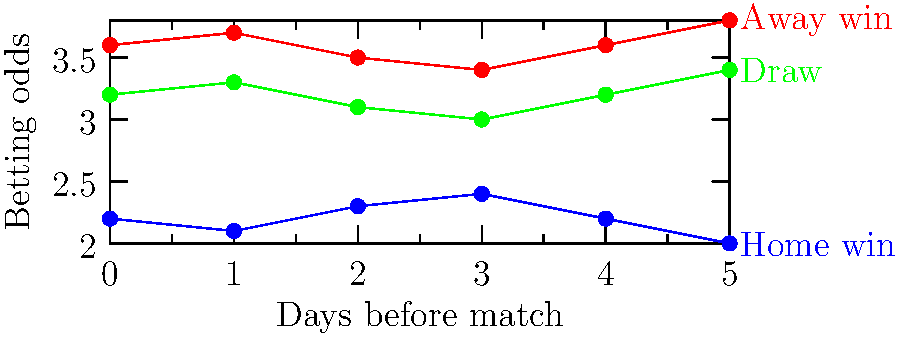Given the graph showing betting odds fluctuations for a football match over the 5 days leading up to the game, what can be inferred about the bookmakers' perception of the most likely outcome on the day of the match (Day 0)? To determine the bookmakers' perception of the most likely outcome on the day of the match, we need to analyze the betting odds for each outcome on Day 0:

1. Identify the odds for each outcome on Day 0:
   - Home win: 2.0
   - Draw: 3.4
   - Away win: 3.8

2. Understand the relationship between odds and probability:
   - Lower odds indicate a higher probability of occurrence
   - Higher odds indicate a lower probability of occurrence

3. Compare the odds:
   - Home win (2.0) has the lowest odds
   - Draw (3.4) has the second-lowest odds
   - Away win (3.8) has the highest odds

4. Interpret the odds:
   - The home win, with the lowest odds, is considered the most likely outcome
   - The draw is considered the second most likely outcome
   - The away win is considered the least likely outcome

5. Conclusion:
   Based on the betting odds on the day of the match (Day 0), bookmakers perceive a home win as the most likely outcome.
Answer: Home win 